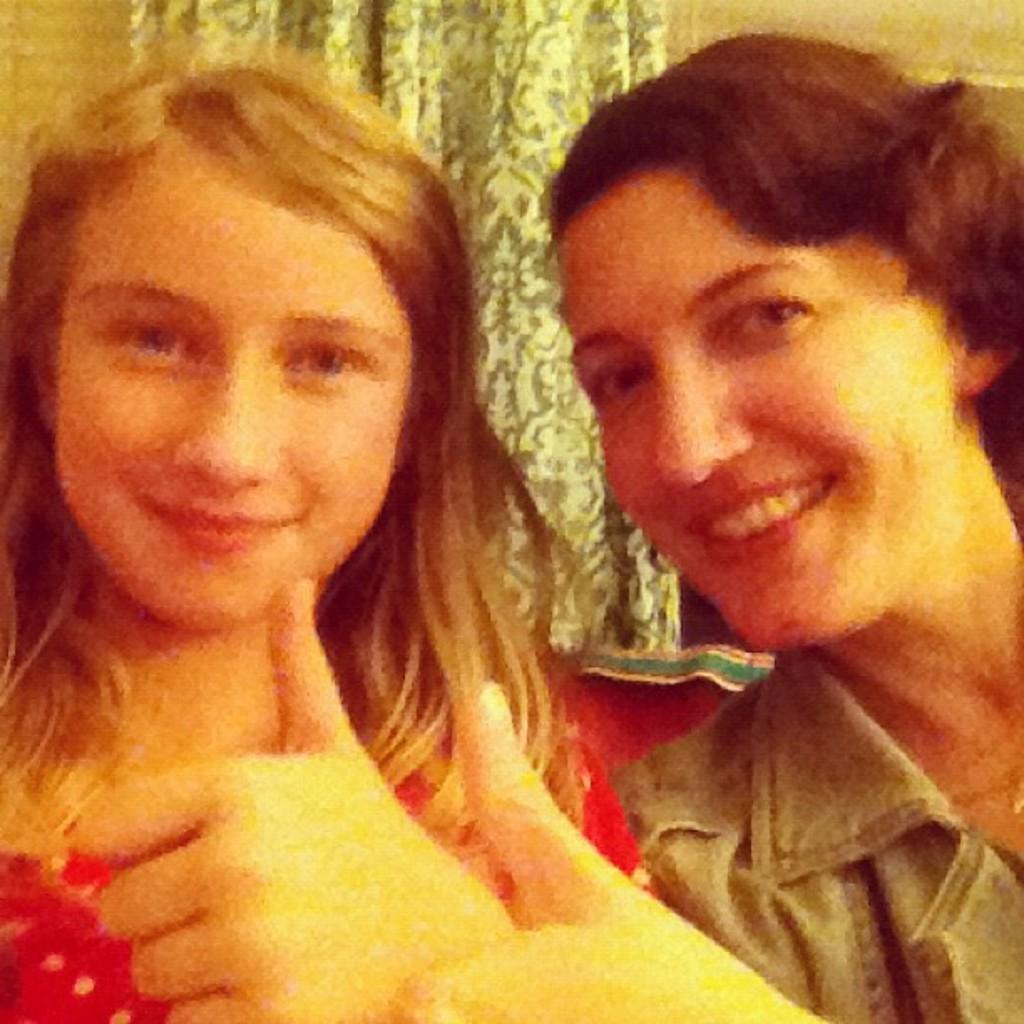In one or two sentences, can you explain what this image depicts? In this image there are two women. A woman is wearing a red dress. They are raising their thumbs up. Behind them there is a curtain. They are smiling. 